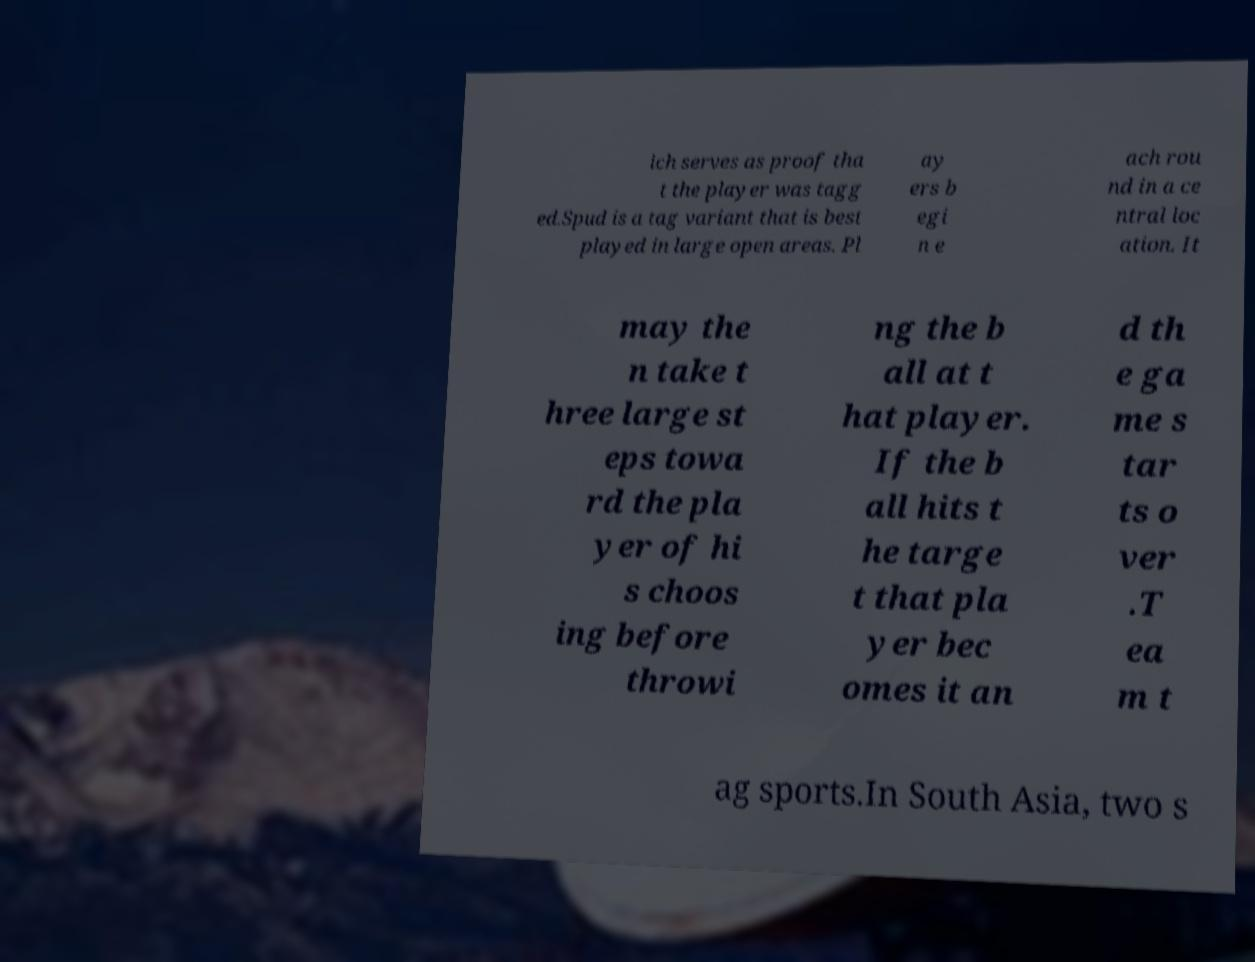What messages or text are displayed in this image? I need them in a readable, typed format. ich serves as proof tha t the player was tagg ed.Spud is a tag variant that is best played in large open areas. Pl ay ers b egi n e ach rou nd in a ce ntral loc ation. It may the n take t hree large st eps towa rd the pla yer of hi s choos ing before throwi ng the b all at t hat player. If the b all hits t he targe t that pla yer bec omes it an d th e ga me s tar ts o ver .T ea m t ag sports.In South Asia, two s 